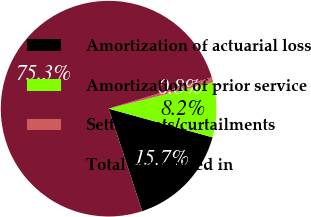<chart> <loc_0><loc_0><loc_500><loc_500><pie_chart><fcel>Amortization of actuarial loss<fcel>Amortization of prior service<fcel>Settlements/curtailments<fcel>Total recognized in<nl><fcel>15.68%<fcel>8.22%<fcel>0.76%<fcel>75.35%<nl></chart> 